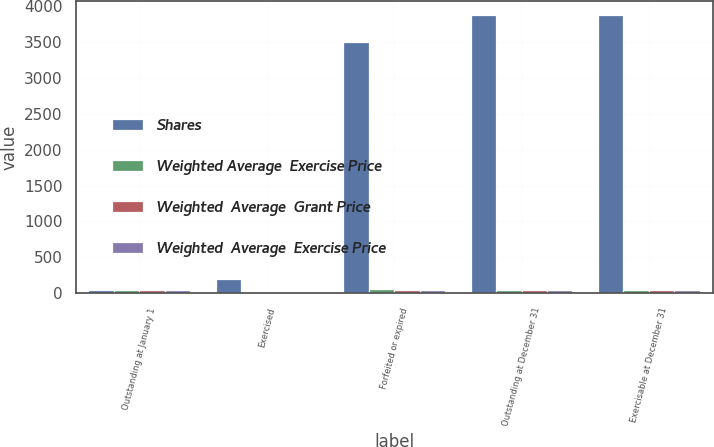Convert chart. <chart><loc_0><loc_0><loc_500><loc_500><stacked_bar_chart><ecel><fcel>Outstanding at January 1<fcel>Exercised<fcel>Forfeited or expired<fcel>Outstanding at December 31<fcel>Exercisable at December 31<nl><fcel>Shares<fcel>52.01<fcel>205<fcel>3502<fcel>3877<fcel>3877<nl><fcel>Weighted Average  Exercise Price<fcel>53.88<fcel>10.32<fcel>66.25<fcel>45<fcel>45<nl><fcel>Weighted  Average  Grant Price<fcel>52.01<fcel>9.25<fcel>49.61<fcel>53.88<fcel>53.88<nl><fcel>Weighted  Average  Exercise Price<fcel>49.29<fcel>8.76<fcel>40.54<fcel>52.01<fcel>52.01<nl></chart> 